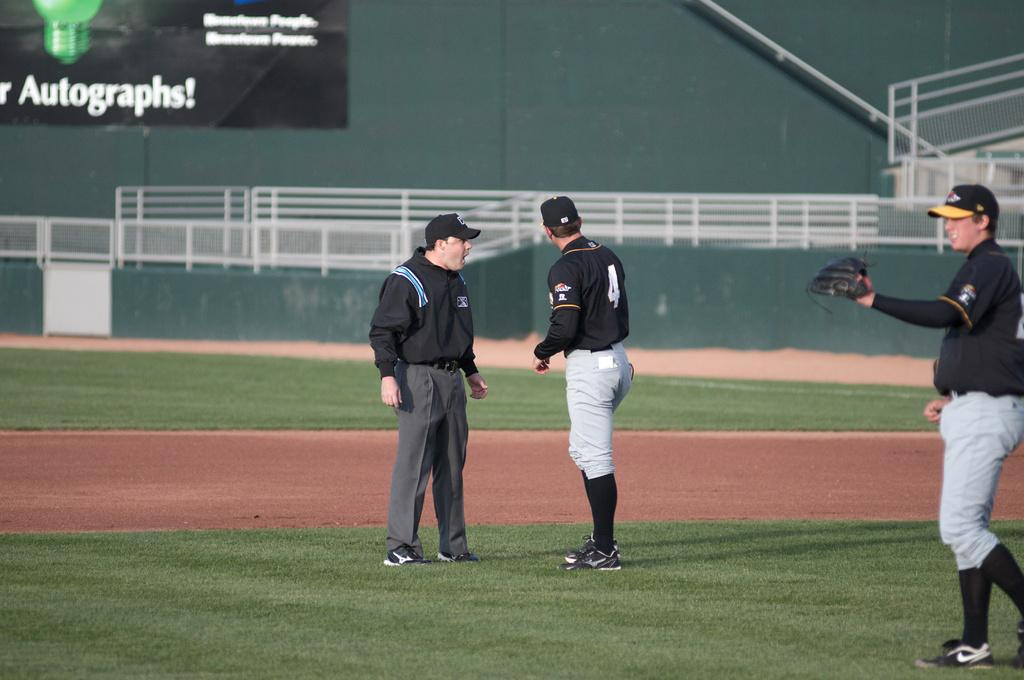<image>
Present a compact description of the photo's key features. Baeball players on a field with a banner in the back that says Autographs. 